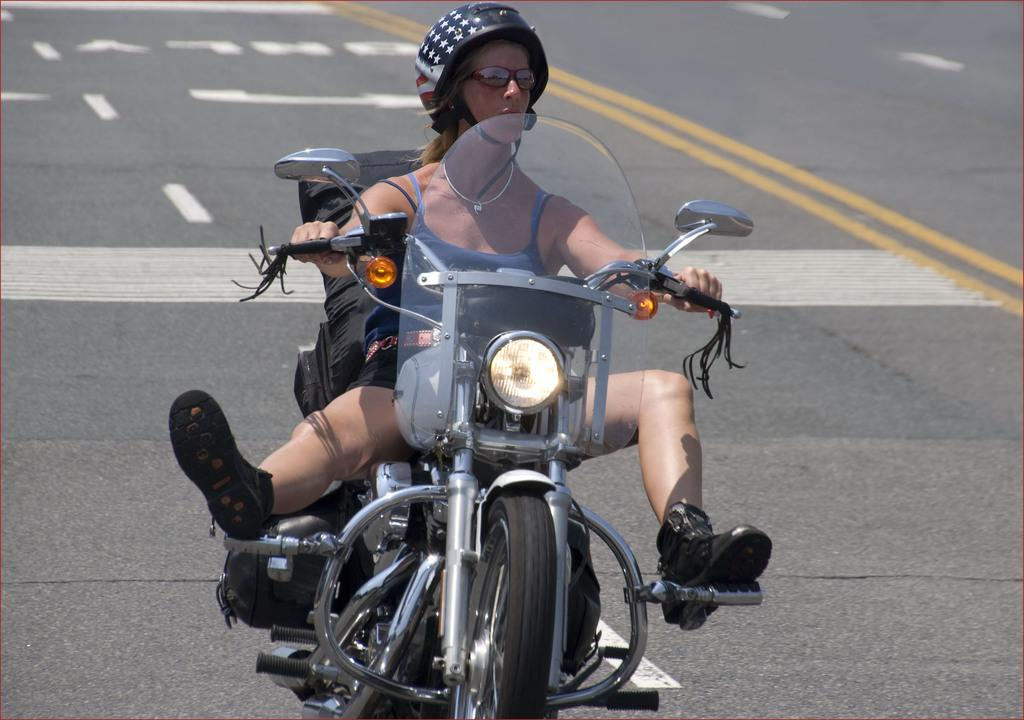Who is the main subject in the image? There is a woman in the image. What is the woman doing in the image? The woman is riding a bike in the image. Where is the woman located in the image? The woman is on the road in the image. What safety gear is the woman wearing in the image? The woman is wearing a black color helmet on her head in the image. What type of kitten can be seen playing in the park in the image? There is no kitten or park present in the image; it features a woman riding a bike on the road. 